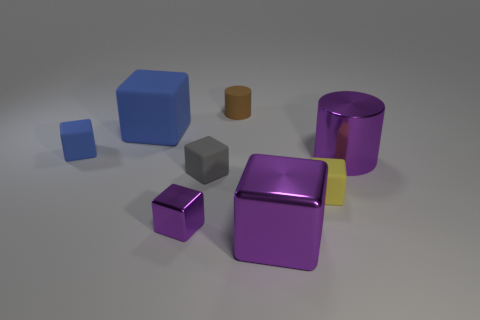How many large objects are the same material as the small cylinder?
Offer a very short reply. 1. There is a big object in front of the gray matte cube; what is its material?
Give a very brief answer. Metal. What is the shape of the blue matte thing that is behind the small rubber block to the left of the tiny gray thing that is in front of the tiny blue matte cube?
Give a very brief answer. Cube. Does the small rubber block to the left of the tiny shiny object have the same color as the large object that is on the left side of the gray matte thing?
Offer a terse response. Yes. Is the number of tiny yellow things that are behind the tiny blue block less than the number of cubes that are to the left of the large matte cube?
Make the answer very short. Yes. There is another thing that is the same shape as the brown matte object; what is its color?
Offer a terse response. Purple. There is a large matte object; is its shape the same as the blue matte thing in front of the large blue matte object?
Offer a terse response. Yes. What number of objects are small blocks on the right side of the brown rubber object or purple metal objects right of the small purple cube?
Provide a succinct answer. 3. What is the gray thing made of?
Offer a very short reply. Rubber. What number of other things are there of the same size as the purple shiny cylinder?
Give a very brief answer. 2. 